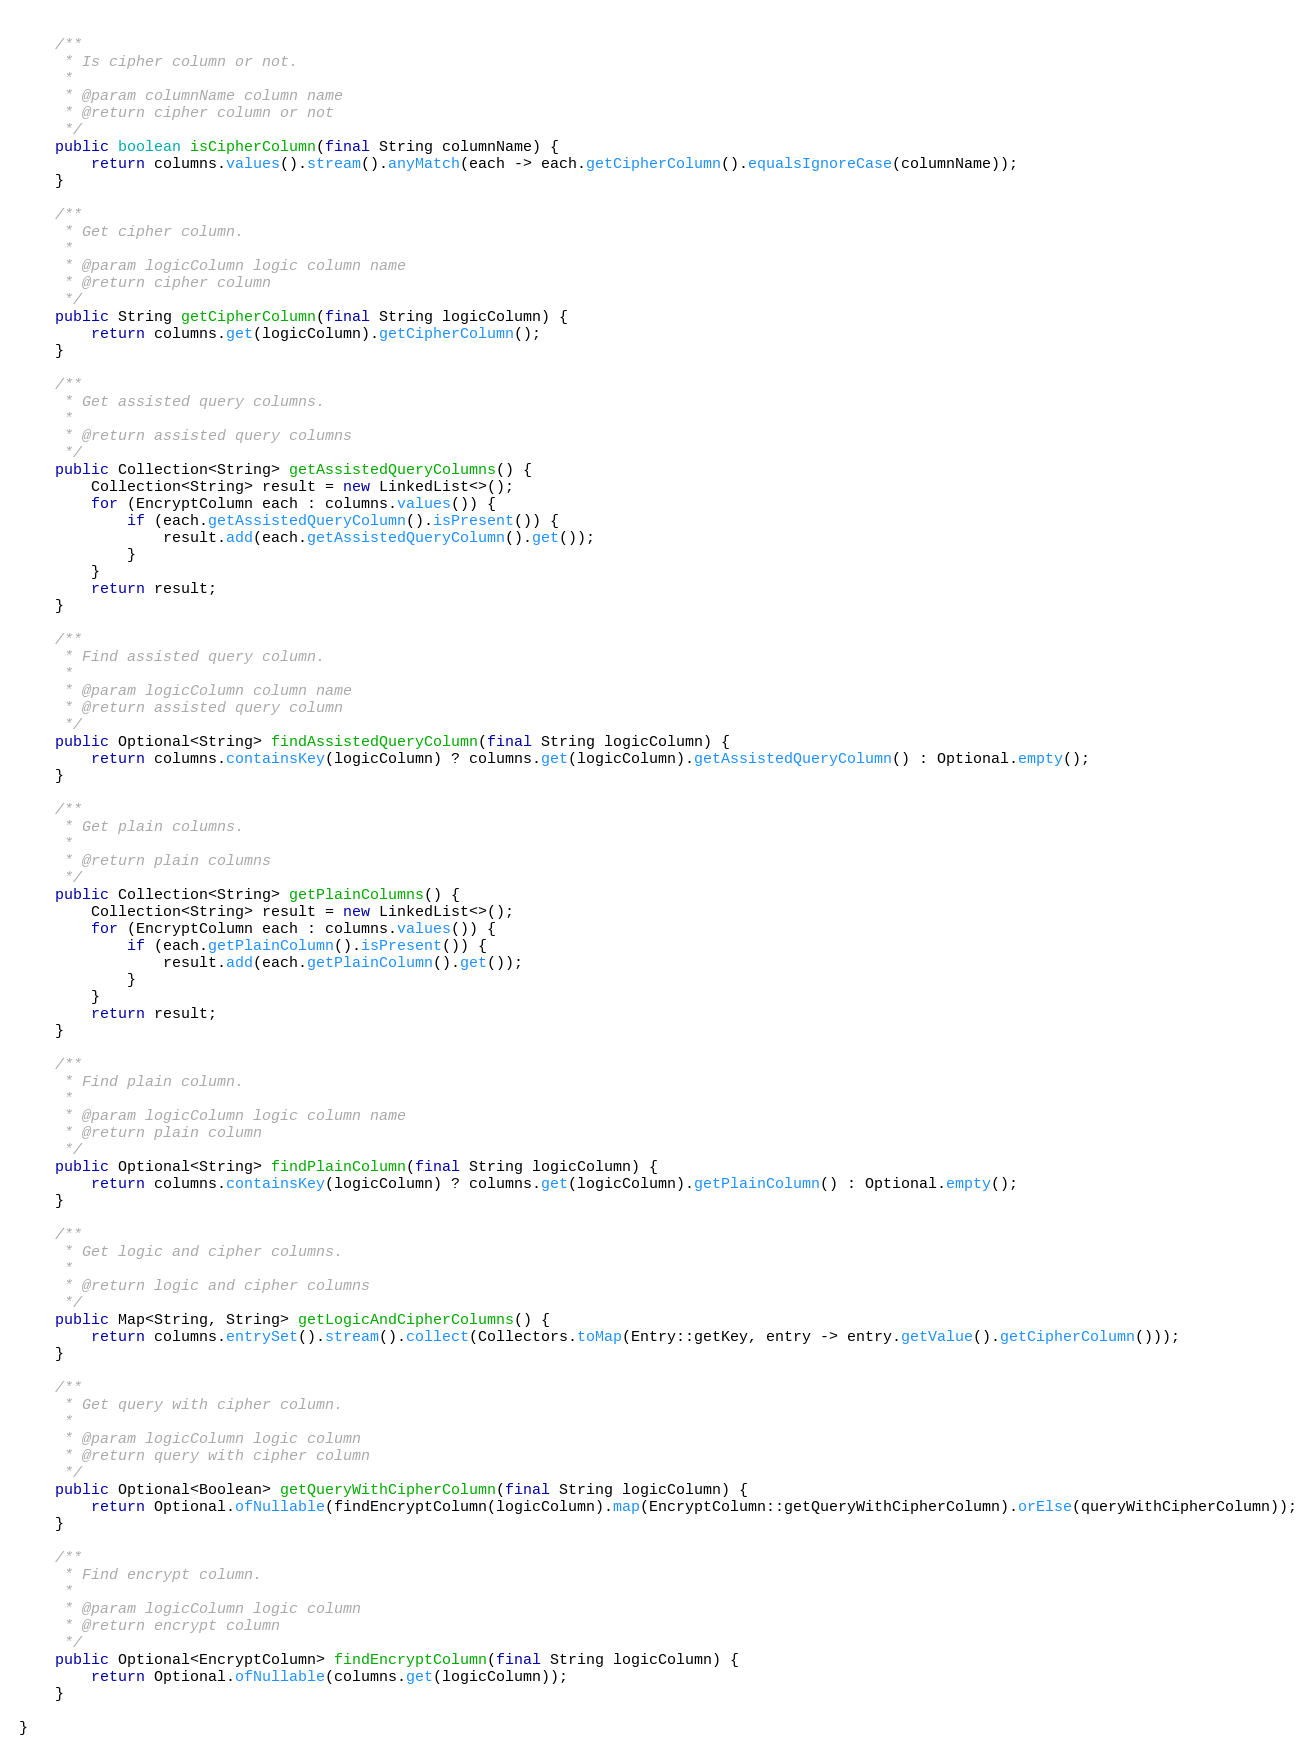Convert code to text. <code><loc_0><loc_0><loc_500><loc_500><_Java_>    
    /**
     * Is cipher column or not.
     *
     * @param columnName column name
     * @return cipher column or not
     */
    public boolean isCipherColumn(final String columnName) {
        return columns.values().stream().anyMatch(each -> each.getCipherColumn().equalsIgnoreCase(columnName));
    }
    
    /**
     * Get cipher column.
     *
     * @param logicColumn logic column name
     * @return cipher column
     */
    public String getCipherColumn(final String logicColumn) {
        return columns.get(logicColumn).getCipherColumn();
    }
    
    /**
     * Get assisted query columns.
     *
     * @return assisted query columns
     */
    public Collection<String> getAssistedQueryColumns() {
        Collection<String> result = new LinkedList<>();
        for (EncryptColumn each : columns.values()) {
            if (each.getAssistedQueryColumn().isPresent()) {
                result.add(each.getAssistedQueryColumn().get());
            }
        }
        return result;
    }
    
    /**
     * Find assisted query column.
     *
     * @param logicColumn column name
     * @return assisted query column
     */
    public Optional<String> findAssistedQueryColumn(final String logicColumn) {
        return columns.containsKey(logicColumn) ? columns.get(logicColumn).getAssistedQueryColumn() : Optional.empty();
    }
    
    /**
     * Get plain columns.
     *
     * @return plain columns
     */
    public Collection<String> getPlainColumns() {
        Collection<String> result = new LinkedList<>();
        for (EncryptColumn each : columns.values()) {
            if (each.getPlainColumn().isPresent()) {
                result.add(each.getPlainColumn().get());
            }
        }
        return result;
    }
    
    /**
     * Find plain column.
     *
     * @param logicColumn logic column name
     * @return plain column
     */
    public Optional<String> findPlainColumn(final String logicColumn) {
        return columns.containsKey(logicColumn) ? columns.get(logicColumn).getPlainColumn() : Optional.empty();
    }
    
    /**
     * Get logic and cipher columns.
     *
     * @return logic and cipher columns
     */
    public Map<String, String> getLogicAndCipherColumns() {
        return columns.entrySet().stream().collect(Collectors.toMap(Entry::getKey, entry -> entry.getValue().getCipherColumn()));
    }
    
    /**
     * Get query with cipher column.
     *
     * @param logicColumn logic column
     * @return query with cipher column
     */
    public Optional<Boolean> getQueryWithCipherColumn(final String logicColumn) {
        return Optional.ofNullable(findEncryptColumn(logicColumn).map(EncryptColumn::getQueryWithCipherColumn).orElse(queryWithCipherColumn));
    }
    
    /**
     * Find encrypt column.
     * 
     * @param logicColumn logic column
     * @return encrypt column
     */
    public Optional<EncryptColumn> findEncryptColumn(final String logicColumn) {
        return Optional.ofNullable(columns.get(logicColumn));
    }
    
}
</code> 